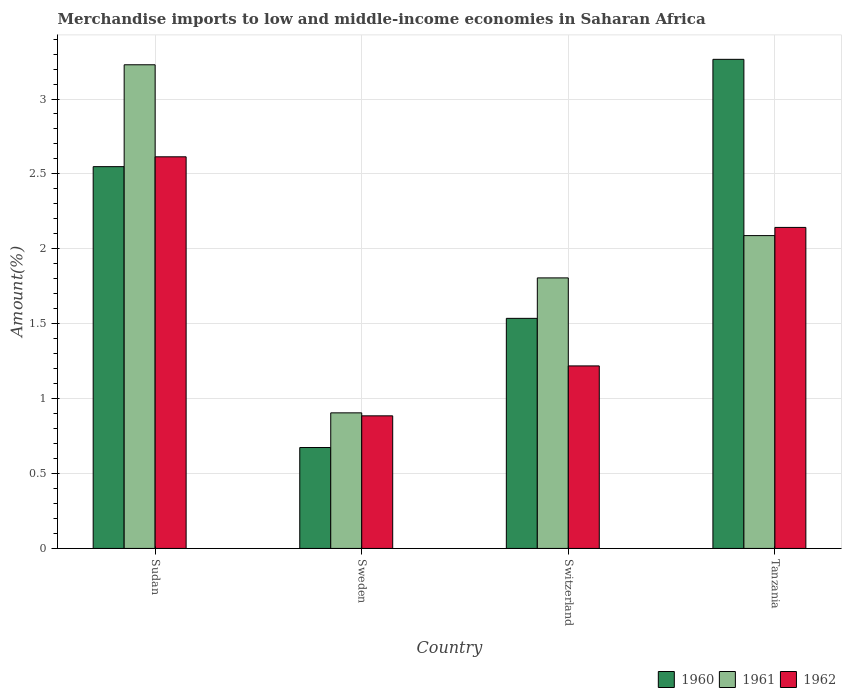How many bars are there on the 2nd tick from the right?
Provide a short and direct response. 3. In how many cases, is the number of bars for a given country not equal to the number of legend labels?
Provide a succinct answer. 0. What is the percentage of amount earned from merchandise imports in 1962 in Tanzania?
Provide a short and direct response. 2.14. Across all countries, what is the maximum percentage of amount earned from merchandise imports in 1961?
Offer a very short reply. 3.23. Across all countries, what is the minimum percentage of amount earned from merchandise imports in 1962?
Keep it short and to the point. 0.89. In which country was the percentage of amount earned from merchandise imports in 1961 maximum?
Your response must be concise. Sudan. What is the total percentage of amount earned from merchandise imports in 1960 in the graph?
Provide a short and direct response. 8.02. What is the difference between the percentage of amount earned from merchandise imports in 1961 in Sweden and that in Switzerland?
Offer a terse response. -0.9. What is the difference between the percentage of amount earned from merchandise imports in 1962 in Sweden and the percentage of amount earned from merchandise imports in 1961 in Sudan?
Your response must be concise. -2.34. What is the average percentage of amount earned from merchandise imports in 1961 per country?
Ensure brevity in your answer.  2.01. What is the difference between the percentage of amount earned from merchandise imports of/in 1961 and percentage of amount earned from merchandise imports of/in 1960 in Sudan?
Make the answer very short. 0.68. What is the ratio of the percentage of amount earned from merchandise imports in 1961 in Sweden to that in Switzerland?
Offer a very short reply. 0.5. Is the percentage of amount earned from merchandise imports in 1960 in Sudan less than that in Switzerland?
Provide a short and direct response. No. Is the difference between the percentage of amount earned from merchandise imports in 1961 in Sudan and Sweden greater than the difference between the percentage of amount earned from merchandise imports in 1960 in Sudan and Sweden?
Give a very brief answer. Yes. What is the difference between the highest and the second highest percentage of amount earned from merchandise imports in 1960?
Ensure brevity in your answer.  -1.01. What is the difference between the highest and the lowest percentage of amount earned from merchandise imports in 1962?
Provide a short and direct response. 1.73. What does the 2nd bar from the left in Tanzania represents?
Make the answer very short. 1961. How many bars are there?
Ensure brevity in your answer.  12. Are all the bars in the graph horizontal?
Give a very brief answer. No. What is the difference between two consecutive major ticks on the Y-axis?
Ensure brevity in your answer.  0.5. Does the graph contain grids?
Your answer should be very brief. Yes. Where does the legend appear in the graph?
Your answer should be compact. Bottom right. How many legend labels are there?
Offer a terse response. 3. What is the title of the graph?
Your answer should be compact. Merchandise imports to low and middle-income economies in Saharan Africa. What is the label or title of the X-axis?
Your answer should be compact. Country. What is the label or title of the Y-axis?
Your answer should be compact. Amount(%). What is the Amount(%) of 1960 in Sudan?
Provide a short and direct response. 2.55. What is the Amount(%) of 1961 in Sudan?
Keep it short and to the point. 3.23. What is the Amount(%) of 1962 in Sudan?
Keep it short and to the point. 2.61. What is the Amount(%) in 1960 in Sweden?
Keep it short and to the point. 0.67. What is the Amount(%) of 1961 in Sweden?
Give a very brief answer. 0.91. What is the Amount(%) in 1962 in Sweden?
Give a very brief answer. 0.89. What is the Amount(%) in 1960 in Switzerland?
Give a very brief answer. 1.54. What is the Amount(%) of 1961 in Switzerland?
Ensure brevity in your answer.  1.81. What is the Amount(%) of 1962 in Switzerland?
Keep it short and to the point. 1.22. What is the Amount(%) of 1960 in Tanzania?
Make the answer very short. 3.26. What is the Amount(%) of 1961 in Tanzania?
Keep it short and to the point. 2.09. What is the Amount(%) in 1962 in Tanzania?
Provide a succinct answer. 2.14. Across all countries, what is the maximum Amount(%) of 1960?
Make the answer very short. 3.26. Across all countries, what is the maximum Amount(%) of 1961?
Offer a very short reply. 3.23. Across all countries, what is the maximum Amount(%) of 1962?
Keep it short and to the point. 2.61. Across all countries, what is the minimum Amount(%) of 1960?
Make the answer very short. 0.67. Across all countries, what is the minimum Amount(%) in 1961?
Give a very brief answer. 0.91. Across all countries, what is the minimum Amount(%) of 1962?
Offer a terse response. 0.89. What is the total Amount(%) in 1960 in the graph?
Give a very brief answer. 8.02. What is the total Amount(%) of 1961 in the graph?
Offer a terse response. 8.03. What is the total Amount(%) in 1962 in the graph?
Keep it short and to the point. 6.86. What is the difference between the Amount(%) of 1960 in Sudan and that in Sweden?
Provide a short and direct response. 1.87. What is the difference between the Amount(%) in 1961 in Sudan and that in Sweden?
Provide a succinct answer. 2.32. What is the difference between the Amount(%) of 1962 in Sudan and that in Sweden?
Offer a very short reply. 1.73. What is the difference between the Amount(%) of 1960 in Sudan and that in Switzerland?
Offer a terse response. 1.01. What is the difference between the Amount(%) in 1961 in Sudan and that in Switzerland?
Keep it short and to the point. 1.42. What is the difference between the Amount(%) in 1962 in Sudan and that in Switzerland?
Offer a terse response. 1.4. What is the difference between the Amount(%) of 1960 in Sudan and that in Tanzania?
Ensure brevity in your answer.  -0.72. What is the difference between the Amount(%) in 1961 in Sudan and that in Tanzania?
Your answer should be compact. 1.14. What is the difference between the Amount(%) in 1962 in Sudan and that in Tanzania?
Provide a succinct answer. 0.47. What is the difference between the Amount(%) in 1960 in Sweden and that in Switzerland?
Give a very brief answer. -0.86. What is the difference between the Amount(%) of 1961 in Sweden and that in Switzerland?
Offer a very short reply. -0.9. What is the difference between the Amount(%) in 1962 in Sweden and that in Switzerland?
Your answer should be very brief. -0.33. What is the difference between the Amount(%) of 1960 in Sweden and that in Tanzania?
Your response must be concise. -2.59. What is the difference between the Amount(%) in 1961 in Sweden and that in Tanzania?
Offer a very short reply. -1.18. What is the difference between the Amount(%) in 1962 in Sweden and that in Tanzania?
Give a very brief answer. -1.26. What is the difference between the Amount(%) of 1960 in Switzerland and that in Tanzania?
Your answer should be very brief. -1.73. What is the difference between the Amount(%) of 1961 in Switzerland and that in Tanzania?
Your answer should be very brief. -0.28. What is the difference between the Amount(%) of 1962 in Switzerland and that in Tanzania?
Your answer should be compact. -0.92. What is the difference between the Amount(%) of 1960 in Sudan and the Amount(%) of 1961 in Sweden?
Keep it short and to the point. 1.64. What is the difference between the Amount(%) in 1960 in Sudan and the Amount(%) in 1962 in Sweden?
Give a very brief answer. 1.66. What is the difference between the Amount(%) of 1961 in Sudan and the Amount(%) of 1962 in Sweden?
Ensure brevity in your answer.  2.34. What is the difference between the Amount(%) of 1960 in Sudan and the Amount(%) of 1961 in Switzerland?
Provide a short and direct response. 0.74. What is the difference between the Amount(%) in 1960 in Sudan and the Amount(%) in 1962 in Switzerland?
Make the answer very short. 1.33. What is the difference between the Amount(%) of 1961 in Sudan and the Amount(%) of 1962 in Switzerland?
Your answer should be very brief. 2.01. What is the difference between the Amount(%) of 1960 in Sudan and the Amount(%) of 1961 in Tanzania?
Provide a short and direct response. 0.46. What is the difference between the Amount(%) in 1960 in Sudan and the Amount(%) in 1962 in Tanzania?
Keep it short and to the point. 0.41. What is the difference between the Amount(%) in 1961 in Sudan and the Amount(%) in 1962 in Tanzania?
Give a very brief answer. 1.09. What is the difference between the Amount(%) of 1960 in Sweden and the Amount(%) of 1961 in Switzerland?
Provide a short and direct response. -1.13. What is the difference between the Amount(%) of 1960 in Sweden and the Amount(%) of 1962 in Switzerland?
Offer a very short reply. -0.54. What is the difference between the Amount(%) of 1961 in Sweden and the Amount(%) of 1962 in Switzerland?
Offer a terse response. -0.31. What is the difference between the Amount(%) of 1960 in Sweden and the Amount(%) of 1961 in Tanzania?
Give a very brief answer. -1.41. What is the difference between the Amount(%) of 1960 in Sweden and the Amount(%) of 1962 in Tanzania?
Provide a succinct answer. -1.47. What is the difference between the Amount(%) of 1961 in Sweden and the Amount(%) of 1962 in Tanzania?
Provide a succinct answer. -1.24. What is the difference between the Amount(%) of 1960 in Switzerland and the Amount(%) of 1961 in Tanzania?
Ensure brevity in your answer.  -0.55. What is the difference between the Amount(%) in 1960 in Switzerland and the Amount(%) in 1962 in Tanzania?
Offer a terse response. -0.61. What is the difference between the Amount(%) in 1961 in Switzerland and the Amount(%) in 1962 in Tanzania?
Make the answer very short. -0.34. What is the average Amount(%) in 1960 per country?
Your answer should be compact. 2.01. What is the average Amount(%) of 1961 per country?
Provide a succinct answer. 2.01. What is the average Amount(%) in 1962 per country?
Make the answer very short. 1.72. What is the difference between the Amount(%) of 1960 and Amount(%) of 1961 in Sudan?
Provide a succinct answer. -0.68. What is the difference between the Amount(%) of 1960 and Amount(%) of 1962 in Sudan?
Your answer should be compact. -0.07. What is the difference between the Amount(%) in 1961 and Amount(%) in 1962 in Sudan?
Offer a terse response. 0.61. What is the difference between the Amount(%) of 1960 and Amount(%) of 1961 in Sweden?
Provide a short and direct response. -0.23. What is the difference between the Amount(%) in 1960 and Amount(%) in 1962 in Sweden?
Your answer should be very brief. -0.21. What is the difference between the Amount(%) in 1960 and Amount(%) in 1961 in Switzerland?
Your answer should be compact. -0.27. What is the difference between the Amount(%) in 1960 and Amount(%) in 1962 in Switzerland?
Your answer should be compact. 0.32. What is the difference between the Amount(%) in 1961 and Amount(%) in 1962 in Switzerland?
Offer a very short reply. 0.59. What is the difference between the Amount(%) in 1960 and Amount(%) in 1961 in Tanzania?
Keep it short and to the point. 1.18. What is the difference between the Amount(%) in 1960 and Amount(%) in 1962 in Tanzania?
Give a very brief answer. 1.12. What is the difference between the Amount(%) of 1961 and Amount(%) of 1962 in Tanzania?
Provide a short and direct response. -0.05. What is the ratio of the Amount(%) of 1960 in Sudan to that in Sweden?
Ensure brevity in your answer.  3.78. What is the ratio of the Amount(%) in 1961 in Sudan to that in Sweden?
Keep it short and to the point. 3.57. What is the ratio of the Amount(%) of 1962 in Sudan to that in Sweden?
Your response must be concise. 2.95. What is the ratio of the Amount(%) in 1960 in Sudan to that in Switzerland?
Offer a terse response. 1.66. What is the ratio of the Amount(%) of 1961 in Sudan to that in Switzerland?
Offer a terse response. 1.79. What is the ratio of the Amount(%) in 1962 in Sudan to that in Switzerland?
Make the answer very short. 2.15. What is the ratio of the Amount(%) of 1960 in Sudan to that in Tanzania?
Give a very brief answer. 0.78. What is the ratio of the Amount(%) in 1961 in Sudan to that in Tanzania?
Provide a succinct answer. 1.55. What is the ratio of the Amount(%) in 1962 in Sudan to that in Tanzania?
Your answer should be compact. 1.22. What is the ratio of the Amount(%) in 1960 in Sweden to that in Switzerland?
Keep it short and to the point. 0.44. What is the ratio of the Amount(%) in 1961 in Sweden to that in Switzerland?
Give a very brief answer. 0.5. What is the ratio of the Amount(%) in 1962 in Sweden to that in Switzerland?
Your answer should be compact. 0.73. What is the ratio of the Amount(%) in 1960 in Sweden to that in Tanzania?
Offer a very short reply. 0.21. What is the ratio of the Amount(%) in 1961 in Sweden to that in Tanzania?
Offer a terse response. 0.43. What is the ratio of the Amount(%) of 1962 in Sweden to that in Tanzania?
Provide a short and direct response. 0.41. What is the ratio of the Amount(%) of 1960 in Switzerland to that in Tanzania?
Offer a very short reply. 0.47. What is the ratio of the Amount(%) of 1961 in Switzerland to that in Tanzania?
Give a very brief answer. 0.86. What is the ratio of the Amount(%) of 1962 in Switzerland to that in Tanzania?
Ensure brevity in your answer.  0.57. What is the difference between the highest and the second highest Amount(%) in 1960?
Offer a terse response. 0.72. What is the difference between the highest and the second highest Amount(%) of 1961?
Ensure brevity in your answer.  1.14. What is the difference between the highest and the second highest Amount(%) in 1962?
Make the answer very short. 0.47. What is the difference between the highest and the lowest Amount(%) in 1960?
Give a very brief answer. 2.59. What is the difference between the highest and the lowest Amount(%) of 1961?
Make the answer very short. 2.32. What is the difference between the highest and the lowest Amount(%) of 1962?
Keep it short and to the point. 1.73. 